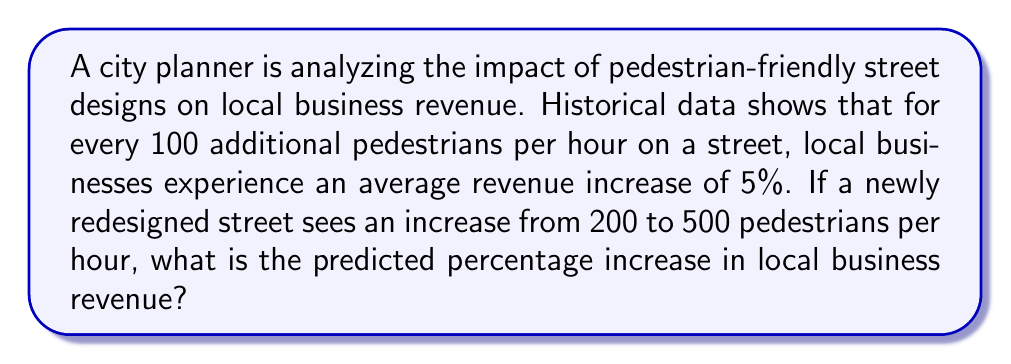Show me your answer to this math problem. Let's approach this step-by-step:

1) First, calculate the increase in pedestrian traffic:
   $500 - 200 = 300$ additional pedestrians per hour

2) Convert this to units of 100 pedestrians:
   $300 \div 100 = 3$ units of 100 pedestrians

3) Each unit of 100 pedestrians corresponds to a 5% increase in revenue.
   So, we multiply the number of units by 5%:
   
   $3 \times 5\% = 3 \times 0.05 = 0.15 = 15\%$

4) Therefore, the predicted percentage increase in local business revenue is 15%.

This can be expressed mathematically as:

$$\text{Revenue Increase} = \frac{\text{Pedestrian Increase}}{100} \times 5\%$$

$$= \frac{500 - 200}{100} \times 5\% = \frac{300}{100} \times 5\% = 3 \times 5\% = 15\%$$
Answer: 15% 